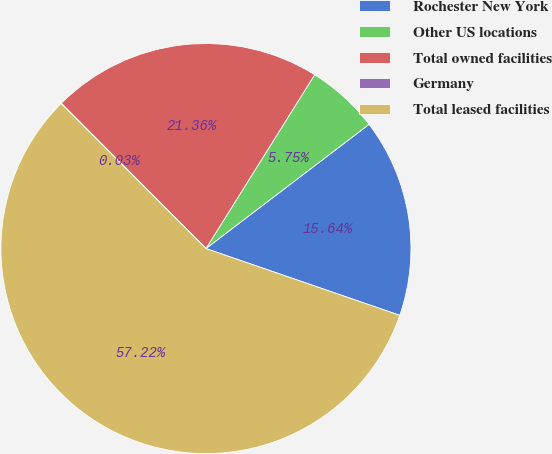Convert chart to OTSL. <chart><loc_0><loc_0><loc_500><loc_500><pie_chart><fcel>Rochester New York<fcel>Other US locations<fcel>Total owned facilities<fcel>Germany<fcel>Total leased facilities<nl><fcel>15.64%<fcel>5.75%<fcel>21.36%<fcel>0.03%<fcel>57.23%<nl></chart> 